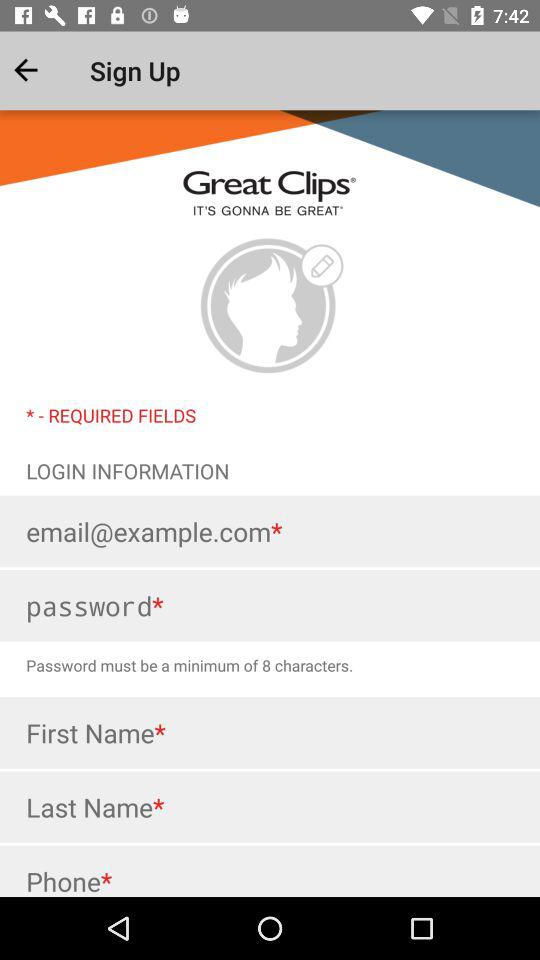What is the name of the application? The name of the application is "Great Clips". 